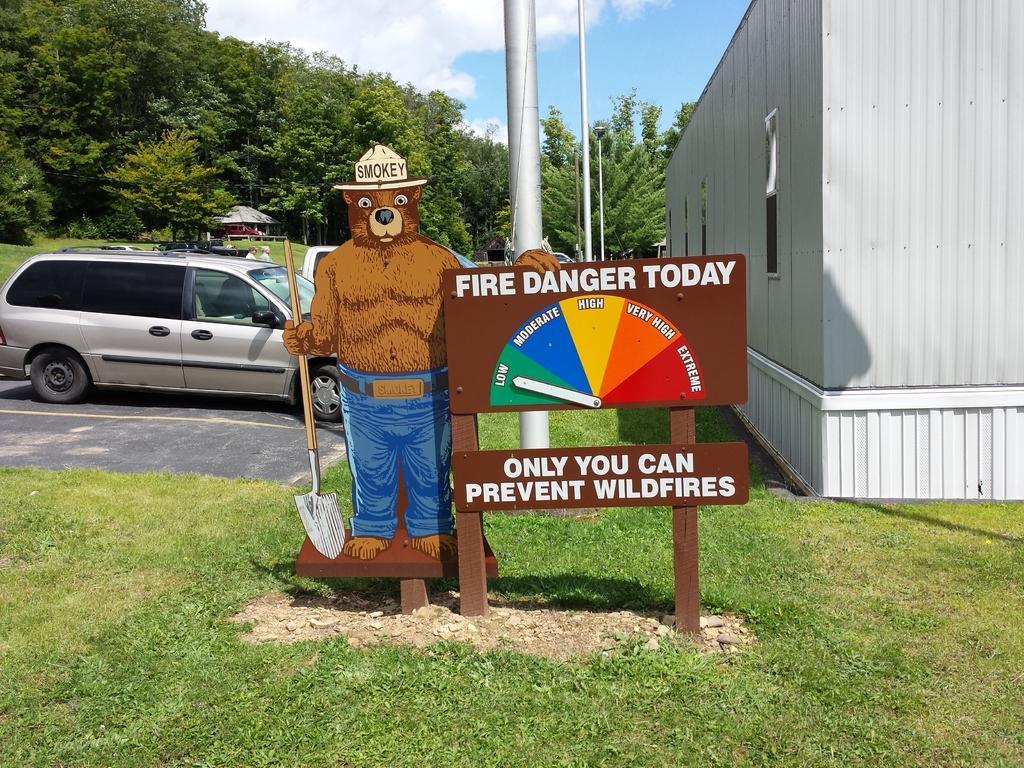Please provide a concise description of this image. In this image there is a bear and a board on that board there is some text, in the background there are cars on the road there are trees, shed, poles and cloudy sky.. 